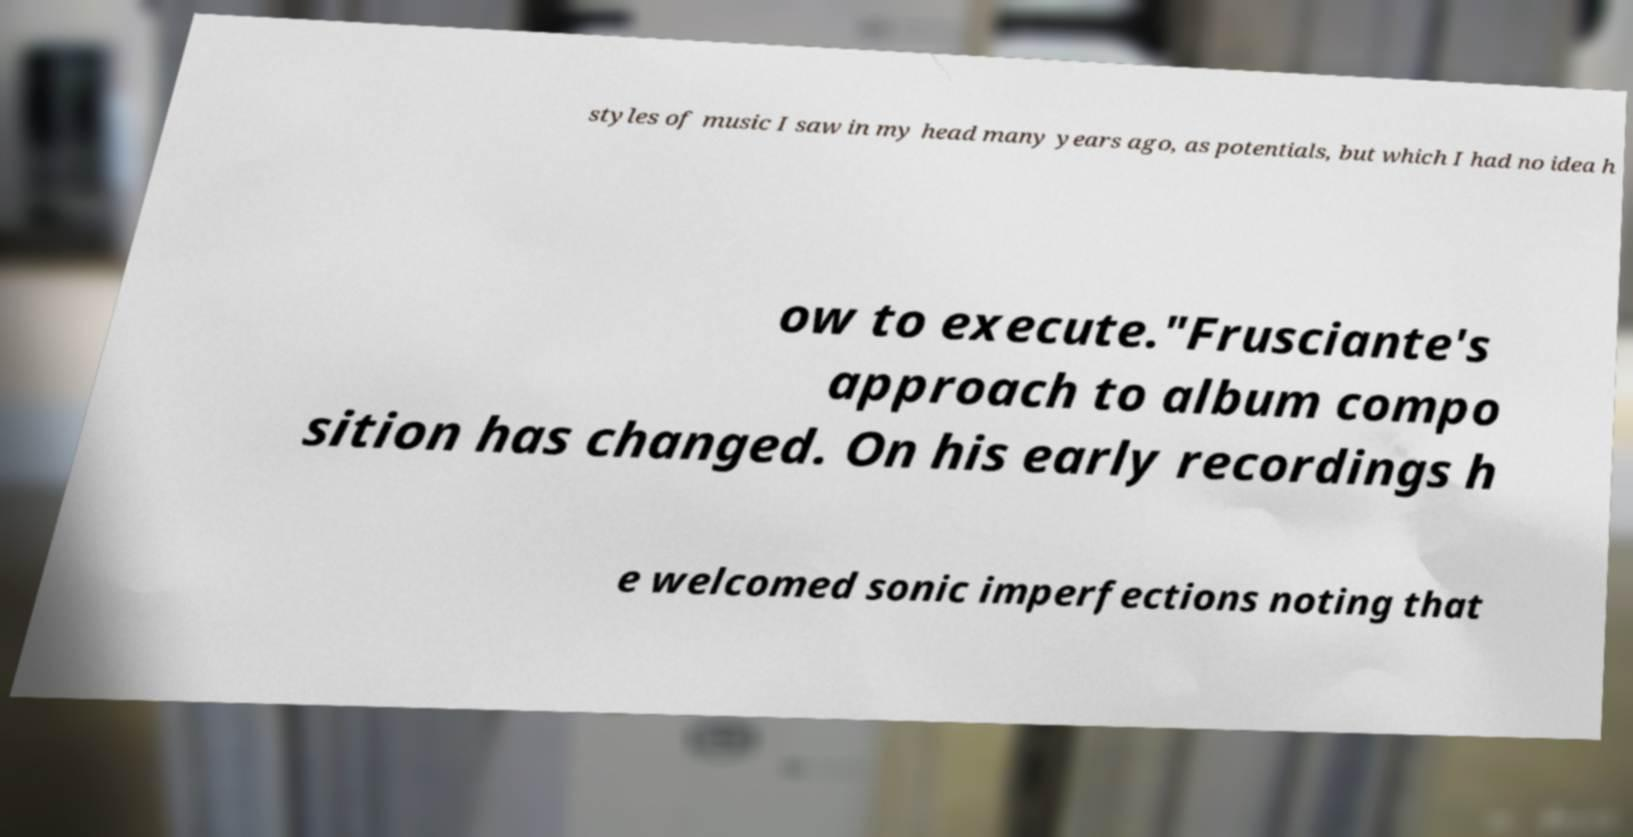Please identify and transcribe the text found in this image. styles of music I saw in my head many years ago, as potentials, but which I had no idea h ow to execute."Frusciante's approach to album compo sition has changed. On his early recordings h e welcomed sonic imperfections noting that 